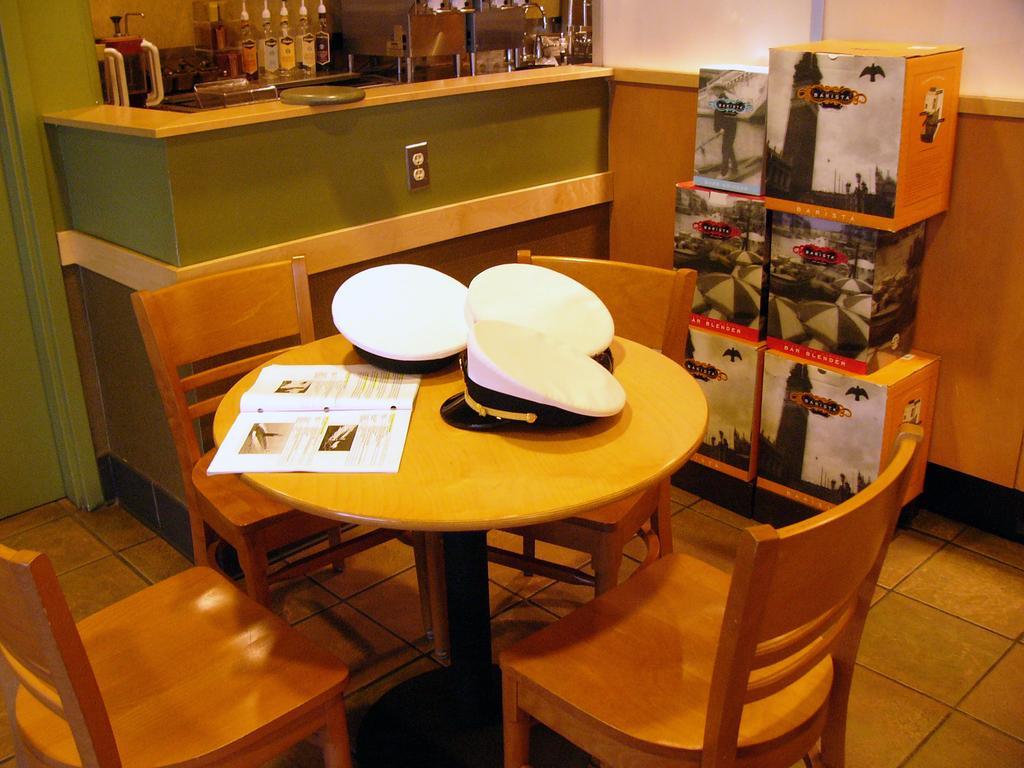Describe this image in one or two sentences. In this image there is a table on the floor. There are chairs surrounded by the table having a book and caps. Right side there are boxes. Behind there is a wooden furniture. Left side there is a cabinet having bottles and few objects. Background there is a wall having a door. 